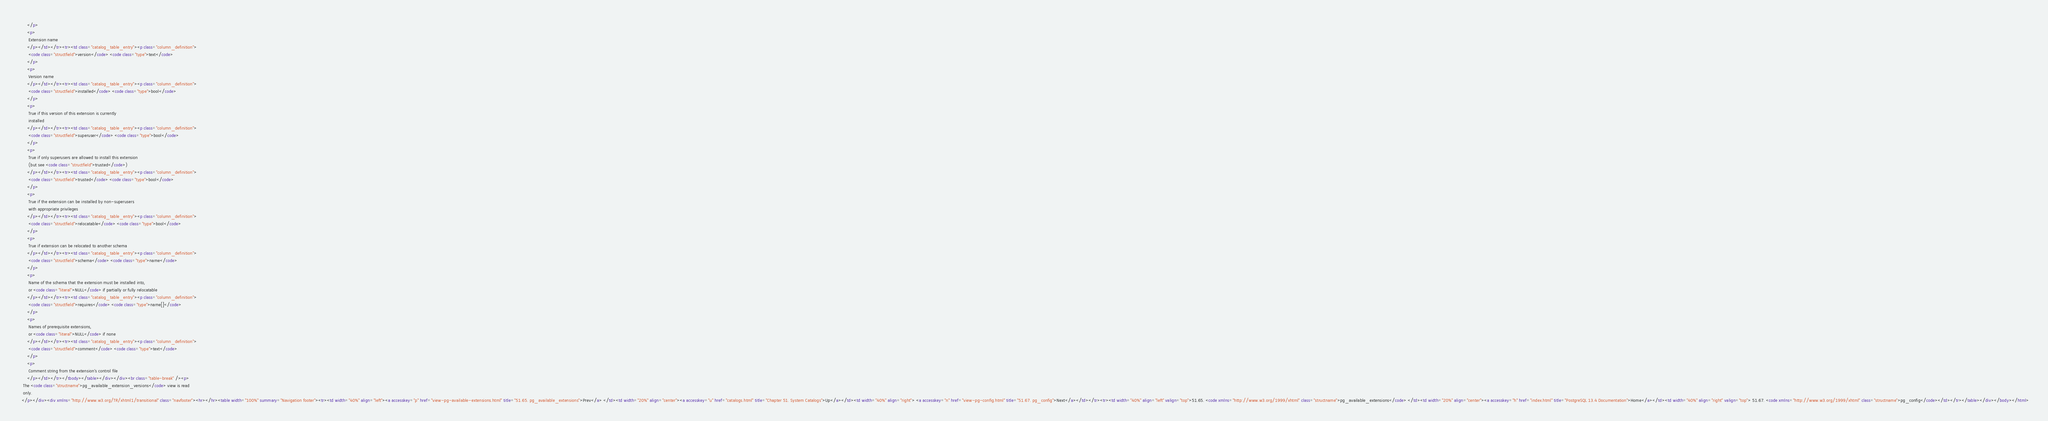<code> <loc_0><loc_0><loc_500><loc_500><_HTML_>      </p>
      <p>
       Extension name
      </p></td></tr><tr><td class="catalog_table_entry"><p class="column_definition">
       <code class="structfield">version</code> <code class="type">text</code>
      </p>
      <p>
       Version name
      </p></td></tr><tr><td class="catalog_table_entry"><p class="column_definition">
       <code class="structfield">installed</code> <code class="type">bool</code>
      </p>
      <p>
       True if this version of this extension is currently
       installed
      </p></td></tr><tr><td class="catalog_table_entry"><p class="column_definition">
       <code class="structfield">superuser</code> <code class="type">bool</code>
      </p>
      <p>
       True if only superusers are allowed to install this extension
       (but see <code class="structfield">trusted</code>)
      </p></td></tr><tr><td class="catalog_table_entry"><p class="column_definition">
       <code class="structfield">trusted</code> <code class="type">bool</code>
      </p>
      <p>
       True if the extension can be installed by non-superusers
       with appropriate privileges
      </p></td></tr><tr><td class="catalog_table_entry"><p class="column_definition">
       <code class="structfield">relocatable</code> <code class="type">bool</code>
      </p>
      <p>
       True if extension can be relocated to another schema
      </p></td></tr><tr><td class="catalog_table_entry"><p class="column_definition">
       <code class="structfield">schema</code> <code class="type">name</code>
      </p>
      <p>
       Name of the schema that the extension must be installed into,
       or <code class="literal">NULL</code> if partially or fully relocatable
      </p></td></tr><tr><td class="catalog_table_entry"><p class="column_definition">
       <code class="structfield">requires</code> <code class="type">name[]</code>
      </p>
      <p>
       Names of prerequisite extensions,
       or <code class="literal">NULL</code> if none
      </p></td></tr><tr><td class="catalog_table_entry"><p class="column_definition">
       <code class="structfield">comment</code> <code class="type">text</code>
      </p>
      <p>
       Comment string from the extension's control file
      </p></td></tr></tbody></table></div></div><br class="table-break" /><p>
   The <code class="structname">pg_available_extension_versions</code> view is read
   only.
  </p></div><div xmlns="http://www.w3.org/TR/xhtml1/transitional" class="navfooter"><hr></hr><table width="100%" summary="Navigation footer"><tr><td width="40%" align="left"><a accesskey="p" href="view-pg-available-extensions.html" title="51.65. pg_available_extensions">Prev</a> </td><td width="20%" align="center"><a accesskey="u" href="catalogs.html" title="Chapter 51. System Catalogs">Up</a></td><td width="40%" align="right"> <a accesskey="n" href="view-pg-config.html" title="51.67. pg_config">Next</a></td></tr><tr><td width="40%" align="left" valign="top">51.65. <code xmlns="http://www.w3.org/1999/xhtml" class="structname">pg_available_extensions</code> </td><td width="20%" align="center"><a accesskey="h" href="index.html" title="PostgreSQL 13.4 Documentation">Home</a></td><td width="40%" align="right" valign="top"> 51.67. <code xmlns="http://www.w3.org/1999/xhtml" class="structname">pg_config</code></td></tr></table></div></body></html></code> 